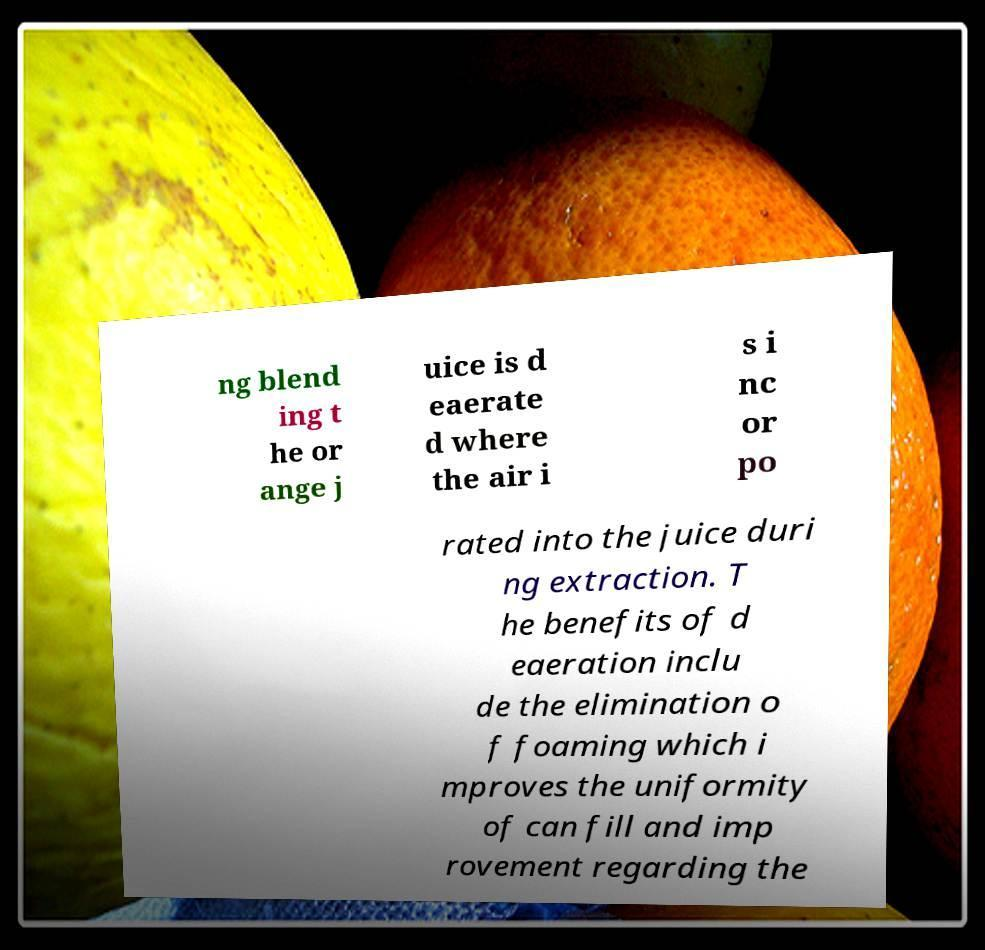For documentation purposes, I need the text within this image transcribed. Could you provide that? ng blend ing t he or ange j uice is d eaerate d where the air i s i nc or po rated into the juice duri ng extraction. T he benefits of d eaeration inclu de the elimination o f foaming which i mproves the uniformity of can fill and imp rovement regarding the 